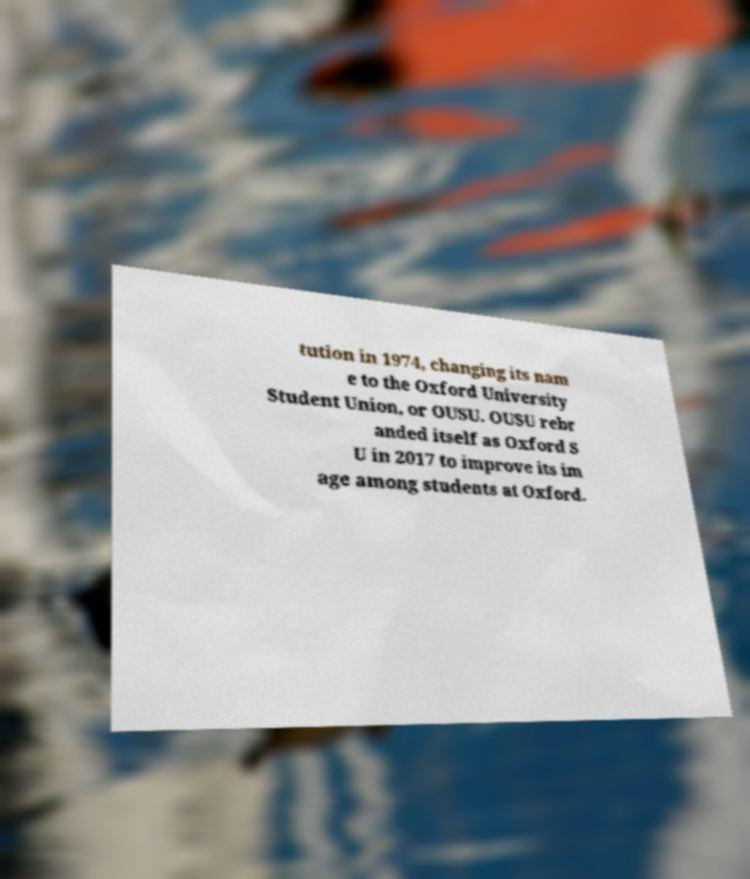Can you accurately transcribe the text from the provided image for me? tution in 1974, changing its nam e to the Oxford University Student Union, or OUSU. OUSU rebr anded itself as Oxford S U in 2017 to improve its im age among students at Oxford. 